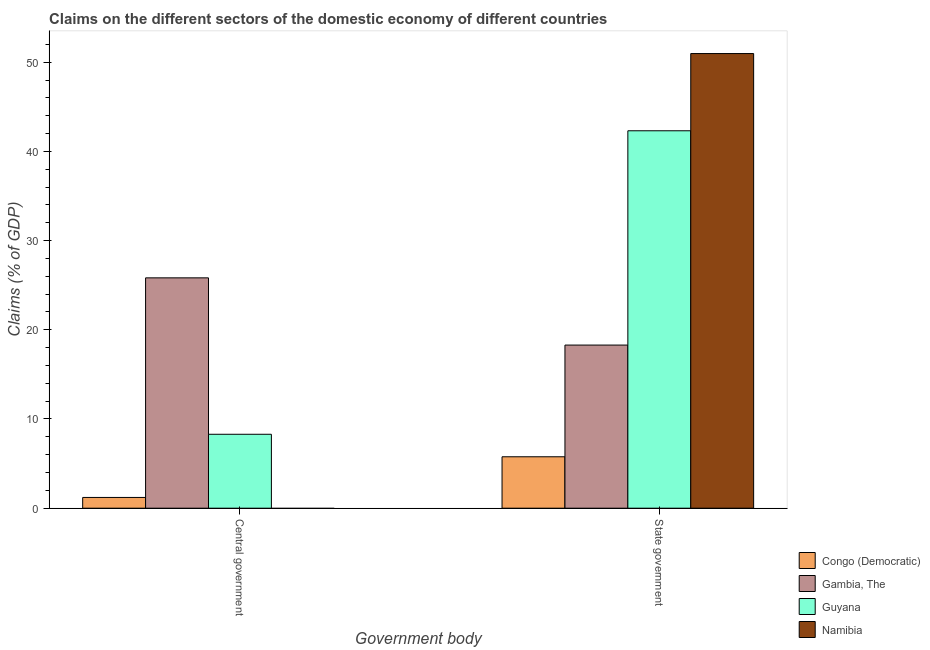How many different coloured bars are there?
Provide a short and direct response. 4. How many groups of bars are there?
Your answer should be very brief. 2. Are the number of bars per tick equal to the number of legend labels?
Ensure brevity in your answer.  No. Are the number of bars on each tick of the X-axis equal?
Give a very brief answer. No. How many bars are there on the 2nd tick from the left?
Your answer should be very brief. 4. How many bars are there on the 2nd tick from the right?
Ensure brevity in your answer.  3. What is the label of the 1st group of bars from the left?
Offer a terse response. Central government. What is the claims on central government in Namibia?
Ensure brevity in your answer.  0. Across all countries, what is the maximum claims on state government?
Provide a succinct answer. 50.97. Across all countries, what is the minimum claims on central government?
Your response must be concise. 0. In which country was the claims on central government maximum?
Make the answer very short. Gambia, The. What is the total claims on state government in the graph?
Provide a short and direct response. 117.33. What is the difference between the claims on central government in Gambia, The and that in Guyana?
Ensure brevity in your answer.  17.53. What is the difference between the claims on central government in Congo (Democratic) and the claims on state government in Namibia?
Provide a succinct answer. -49.76. What is the average claims on central government per country?
Keep it short and to the point. 8.83. What is the difference between the claims on central government and claims on state government in Gambia, The?
Offer a terse response. 7.53. What is the ratio of the claims on state government in Congo (Democratic) to that in Namibia?
Keep it short and to the point. 0.11. Is the claims on state government in Guyana less than that in Congo (Democratic)?
Provide a short and direct response. No. Are all the bars in the graph horizontal?
Your answer should be compact. No. Are the values on the major ticks of Y-axis written in scientific E-notation?
Offer a terse response. No. How are the legend labels stacked?
Ensure brevity in your answer.  Vertical. What is the title of the graph?
Your answer should be very brief. Claims on the different sectors of the domestic economy of different countries. Does "Niger" appear as one of the legend labels in the graph?
Offer a terse response. No. What is the label or title of the X-axis?
Give a very brief answer. Government body. What is the label or title of the Y-axis?
Offer a terse response. Claims (% of GDP). What is the Claims (% of GDP) in Congo (Democratic) in Central government?
Provide a succinct answer. 1.2. What is the Claims (% of GDP) of Gambia, The in Central government?
Your response must be concise. 25.82. What is the Claims (% of GDP) of Guyana in Central government?
Your answer should be compact. 8.29. What is the Claims (% of GDP) of Namibia in Central government?
Keep it short and to the point. 0. What is the Claims (% of GDP) of Congo (Democratic) in State government?
Your answer should be very brief. 5.76. What is the Claims (% of GDP) in Gambia, The in State government?
Offer a very short reply. 18.29. What is the Claims (% of GDP) of Guyana in State government?
Provide a succinct answer. 42.31. What is the Claims (% of GDP) in Namibia in State government?
Your response must be concise. 50.97. Across all Government body, what is the maximum Claims (% of GDP) of Congo (Democratic)?
Keep it short and to the point. 5.76. Across all Government body, what is the maximum Claims (% of GDP) of Gambia, The?
Make the answer very short. 25.82. Across all Government body, what is the maximum Claims (% of GDP) in Guyana?
Make the answer very short. 42.31. Across all Government body, what is the maximum Claims (% of GDP) in Namibia?
Your response must be concise. 50.97. Across all Government body, what is the minimum Claims (% of GDP) in Congo (Democratic)?
Ensure brevity in your answer.  1.2. Across all Government body, what is the minimum Claims (% of GDP) of Gambia, The?
Make the answer very short. 18.29. Across all Government body, what is the minimum Claims (% of GDP) of Guyana?
Make the answer very short. 8.29. Across all Government body, what is the minimum Claims (% of GDP) in Namibia?
Provide a short and direct response. 0. What is the total Claims (% of GDP) in Congo (Democratic) in the graph?
Provide a succinct answer. 6.97. What is the total Claims (% of GDP) in Gambia, The in the graph?
Ensure brevity in your answer.  44.11. What is the total Claims (% of GDP) in Guyana in the graph?
Give a very brief answer. 50.6. What is the total Claims (% of GDP) in Namibia in the graph?
Offer a very short reply. 50.97. What is the difference between the Claims (% of GDP) of Congo (Democratic) in Central government and that in State government?
Keep it short and to the point. -4.56. What is the difference between the Claims (% of GDP) of Gambia, The in Central government and that in State government?
Provide a succinct answer. 7.54. What is the difference between the Claims (% of GDP) in Guyana in Central government and that in State government?
Your answer should be compact. -34.02. What is the difference between the Claims (% of GDP) in Congo (Democratic) in Central government and the Claims (% of GDP) in Gambia, The in State government?
Your answer should be very brief. -17.08. What is the difference between the Claims (% of GDP) of Congo (Democratic) in Central government and the Claims (% of GDP) of Guyana in State government?
Offer a very short reply. -41.1. What is the difference between the Claims (% of GDP) of Congo (Democratic) in Central government and the Claims (% of GDP) of Namibia in State government?
Your answer should be very brief. -49.76. What is the difference between the Claims (% of GDP) in Gambia, The in Central government and the Claims (% of GDP) in Guyana in State government?
Keep it short and to the point. -16.49. What is the difference between the Claims (% of GDP) in Gambia, The in Central government and the Claims (% of GDP) in Namibia in State government?
Keep it short and to the point. -25.15. What is the difference between the Claims (% of GDP) in Guyana in Central government and the Claims (% of GDP) in Namibia in State government?
Provide a succinct answer. -42.68. What is the average Claims (% of GDP) of Congo (Democratic) per Government body?
Your answer should be very brief. 3.48. What is the average Claims (% of GDP) of Gambia, The per Government body?
Your response must be concise. 22.05. What is the average Claims (% of GDP) of Guyana per Government body?
Provide a short and direct response. 25.3. What is the average Claims (% of GDP) in Namibia per Government body?
Your response must be concise. 25.48. What is the difference between the Claims (% of GDP) in Congo (Democratic) and Claims (% of GDP) in Gambia, The in Central government?
Your response must be concise. -24.62. What is the difference between the Claims (% of GDP) in Congo (Democratic) and Claims (% of GDP) in Guyana in Central government?
Offer a very short reply. -7.08. What is the difference between the Claims (% of GDP) in Gambia, The and Claims (% of GDP) in Guyana in Central government?
Your response must be concise. 17.53. What is the difference between the Claims (% of GDP) of Congo (Democratic) and Claims (% of GDP) of Gambia, The in State government?
Your answer should be very brief. -12.52. What is the difference between the Claims (% of GDP) of Congo (Democratic) and Claims (% of GDP) of Guyana in State government?
Keep it short and to the point. -36.55. What is the difference between the Claims (% of GDP) of Congo (Democratic) and Claims (% of GDP) of Namibia in State government?
Provide a short and direct response. -45.2. What is the difference between the Claims (% of GDP) in Gambia, The and Claims (% of GDP) in Guyana in State government?
Make the answer very short. -24.02. What is the difference between the Claims (% of GDP) of Gambia, The and Claims (% of GDP) of Namibia in State government?
Keep it short and to the point. -32.68. What is the difference between the Claims (% of GDP) of Guyana and Claims (% of GDP) of Namibia in State government?
Provide a succinct answer. -8.66. What is the ratio of the Claims (% of GDP) of Congo (Democratic) in Central government to that in State government?
Provide a succinct answer. 0.21. What is the ratio of the Claims (% of GDP) in Gambia, The in Central government to that in State government?
Your answer should be compact. 1.41. What is the ratio of the Claims (% of GDP) of Guyana in Central government to that in State government?
Offer a terse response. 0.2. What is the difference between the highest and the second highest Claims (% of GDP) of Congo (Democratic)?
Give a very brief answer. 4.56. What is the difference between the highest and the second highest Claims (% of GDP) of Gambia, The?
Your answer should be compact. 7.54. What is the difference between the highest and the second highest Claims (% of GDP) of Guyana?
Offer a very short reply. 34.02. What is the difference between the highest and the lowest Claims (% of GDP) of Congo (Democratic)?
Provide a succinct answer. 4.56. What is the difference between the highest and the lowest Claims (% of GDP) in Gambia, The?
Offer a terse response. 7.54. What is the difference between the highest and the lowest Claims (% of GDP) of Guyana?
Provide a succinct answer. 34.02. What is the difference between the highest and the lowest Claims (% of GDP) of Namibia?
Your answer should be very brief. 50.97. 